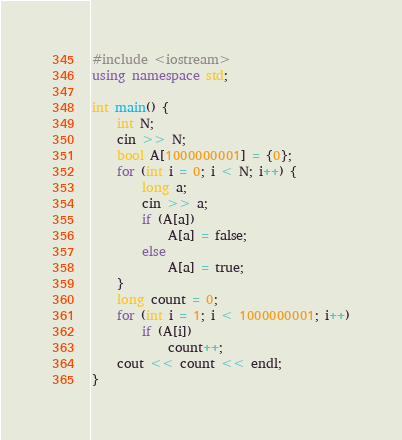Convert code to text. <code><loc_0><loc_0><loc_500><loc_500><_C++_>#include <iostream>
using namespace std;

int main() {
	int N;
	cin >> N;
	bool A[1000000001] = {0};
	for (int i = 0; i < N; i++) {
		long a;
		cin >> a;
		if (A[a])
			A[a] = false;
		else
			A[a] = true;
	}
	long count = 0;
	for (int i = 1; i < 1000000001; i++)
		if (A[i])
			count++;
	cout << count << endl;
}
</code> 